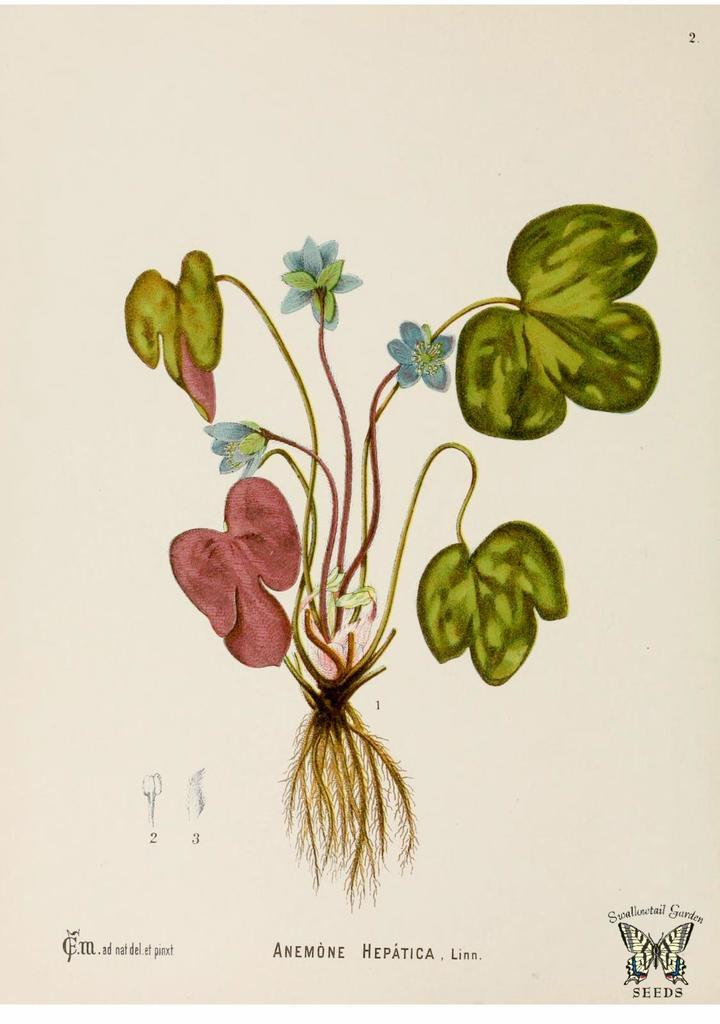What is the main subject of the image? There is a painting in the image. What can be found at the bottom of the painting? There is text at the bottom of the painting. What color is the background of the image? The background of the image is white. Can you see the sister of the artist in the image? There is no person, including the artist or their sister, present in the image; it only features a painting with text at the bottom and a white background. 